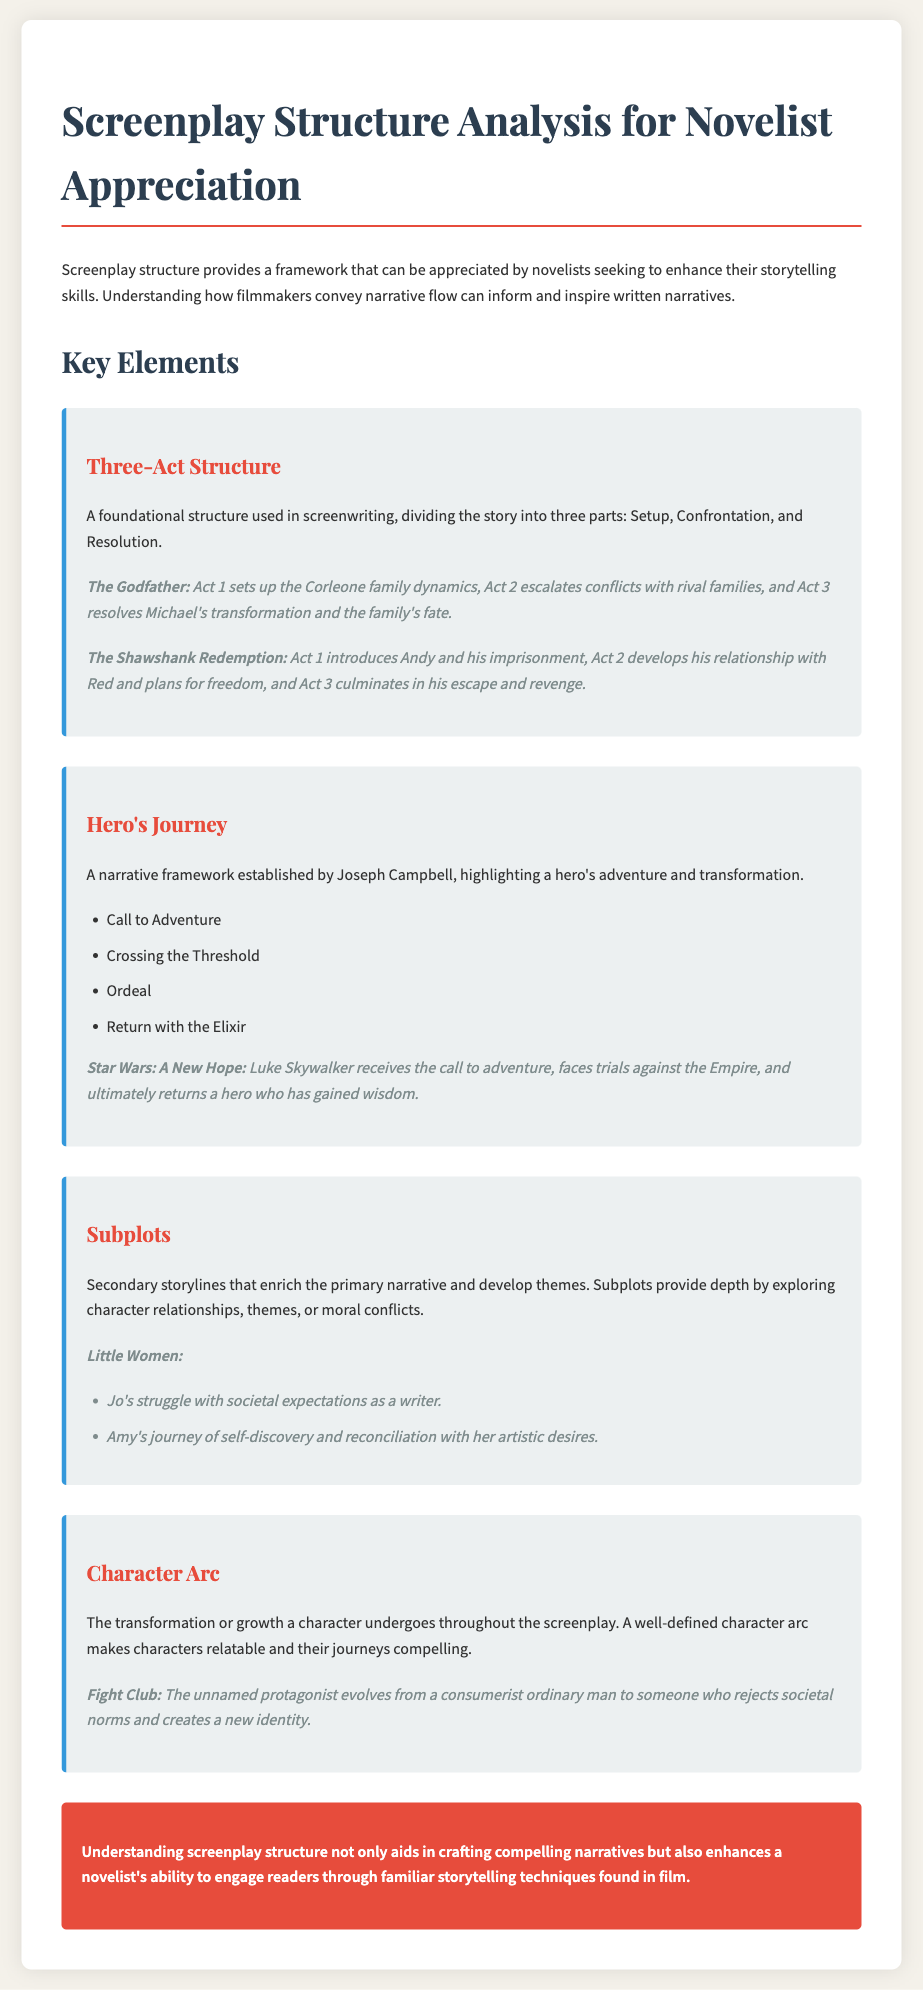What is the title of the document? The title is given in the <title> tag of the HTML, which describes the content of the document.
Answer: Screenplay Structure Analysis for Novelist Appreciation What are the three parts of the Three-Act Structure? The document outlines the Three-Act Structure consisting of Setup, Confrontation, and Resolution.
Answer: Setup, Confrontation, Resolution Who established the Hero's Journey framework? The document mentions Joseph Campbell in connection with the Hero's Journey framework.
Answer: Joseph Campbell What classic film is cited for its character arc example? The document provides an example of character arc from a well-known film.
Answer: Fight Club What subplot does Jo face in Little Women? This subplot is specifically mentioned in relation to character challenges in the narrative.
Answer: Jo's struggle with societal expectations as a writer Which key element outlines secondary storylines? The document includes discussions on different storytelling frameworks, one being secondary storylines.
Answer: Subplots How many key elements are addressed in the document? The document lists several key elements of screenplay structure.
Answer: Four What does understanding screenplay structure enhance? The final summary highlights the benefits of screenplay structure for novelists.
Answer: Engaging readers 